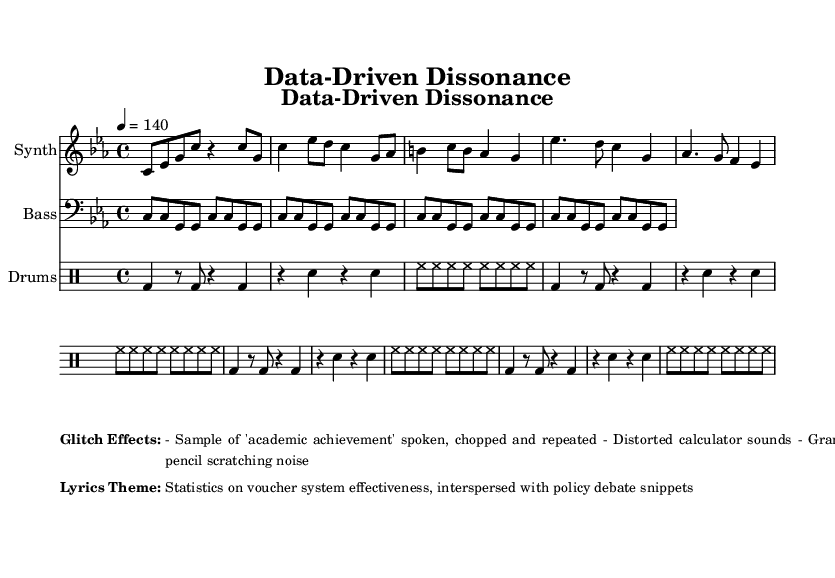What is the key signature of this music? The key signature is indicated at the beginning of the global section, showing C minor with three flats.
Answer: C minor What is the time signature of this music? The time signature is displayed in the global section as 4/4, which means there are four beats in each measure.
Answer: 4/4 What is the tempo marking for this piece? The tempo marking is specified in the global section, indicating a speed of quarter note equals 140 beats per minute.
Answer: 140 How many measures are in the synthesizer part? By analyzing the synth section in the code, there are three distinct parts: intro, verse, and chorus. Counting these, the total number of measures is six.
Answer: 6 What is the primary theme of the lyrics? The lyrics theme is described in the markup section, which emphasizes statistics regarding voucher system effectiveness and snippets of policy debates.
Answer: Statistics on voucher system effectiveness What font size is used for the title in the score? The title font size is specified in the paper section's scoreTitleMarkup as fontsize 3.
Answer: 3 What type of musical effects are mentioned in the markup? The markup section lists specific effects used in the track, focusing on academic achievement samples, distorted calculator sounds, and granulated pencil scratching noise.
Answer: Academic achievement samples 